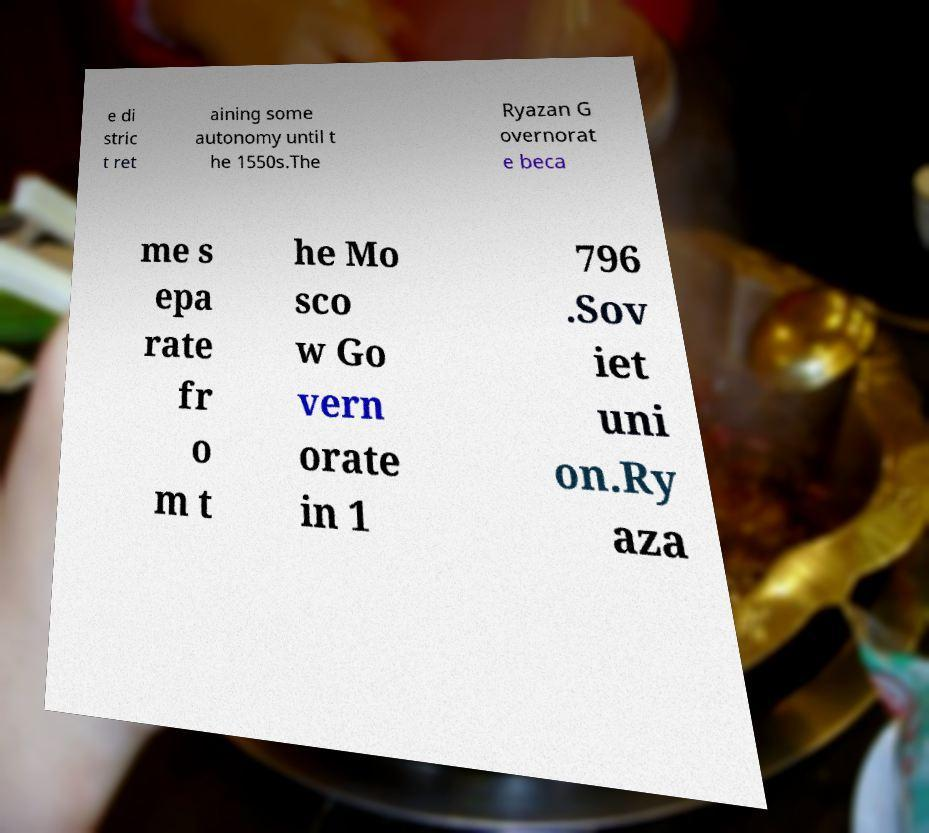Could you extract and type out the text from this image? e di stric t ret aining some autonomy until t he 1550s.The Ryazan G overnorat e beca me s epa rate fr o m t he Mo sco w Go vern orate in 1 796 .Sov iet uni on.Ry aza 